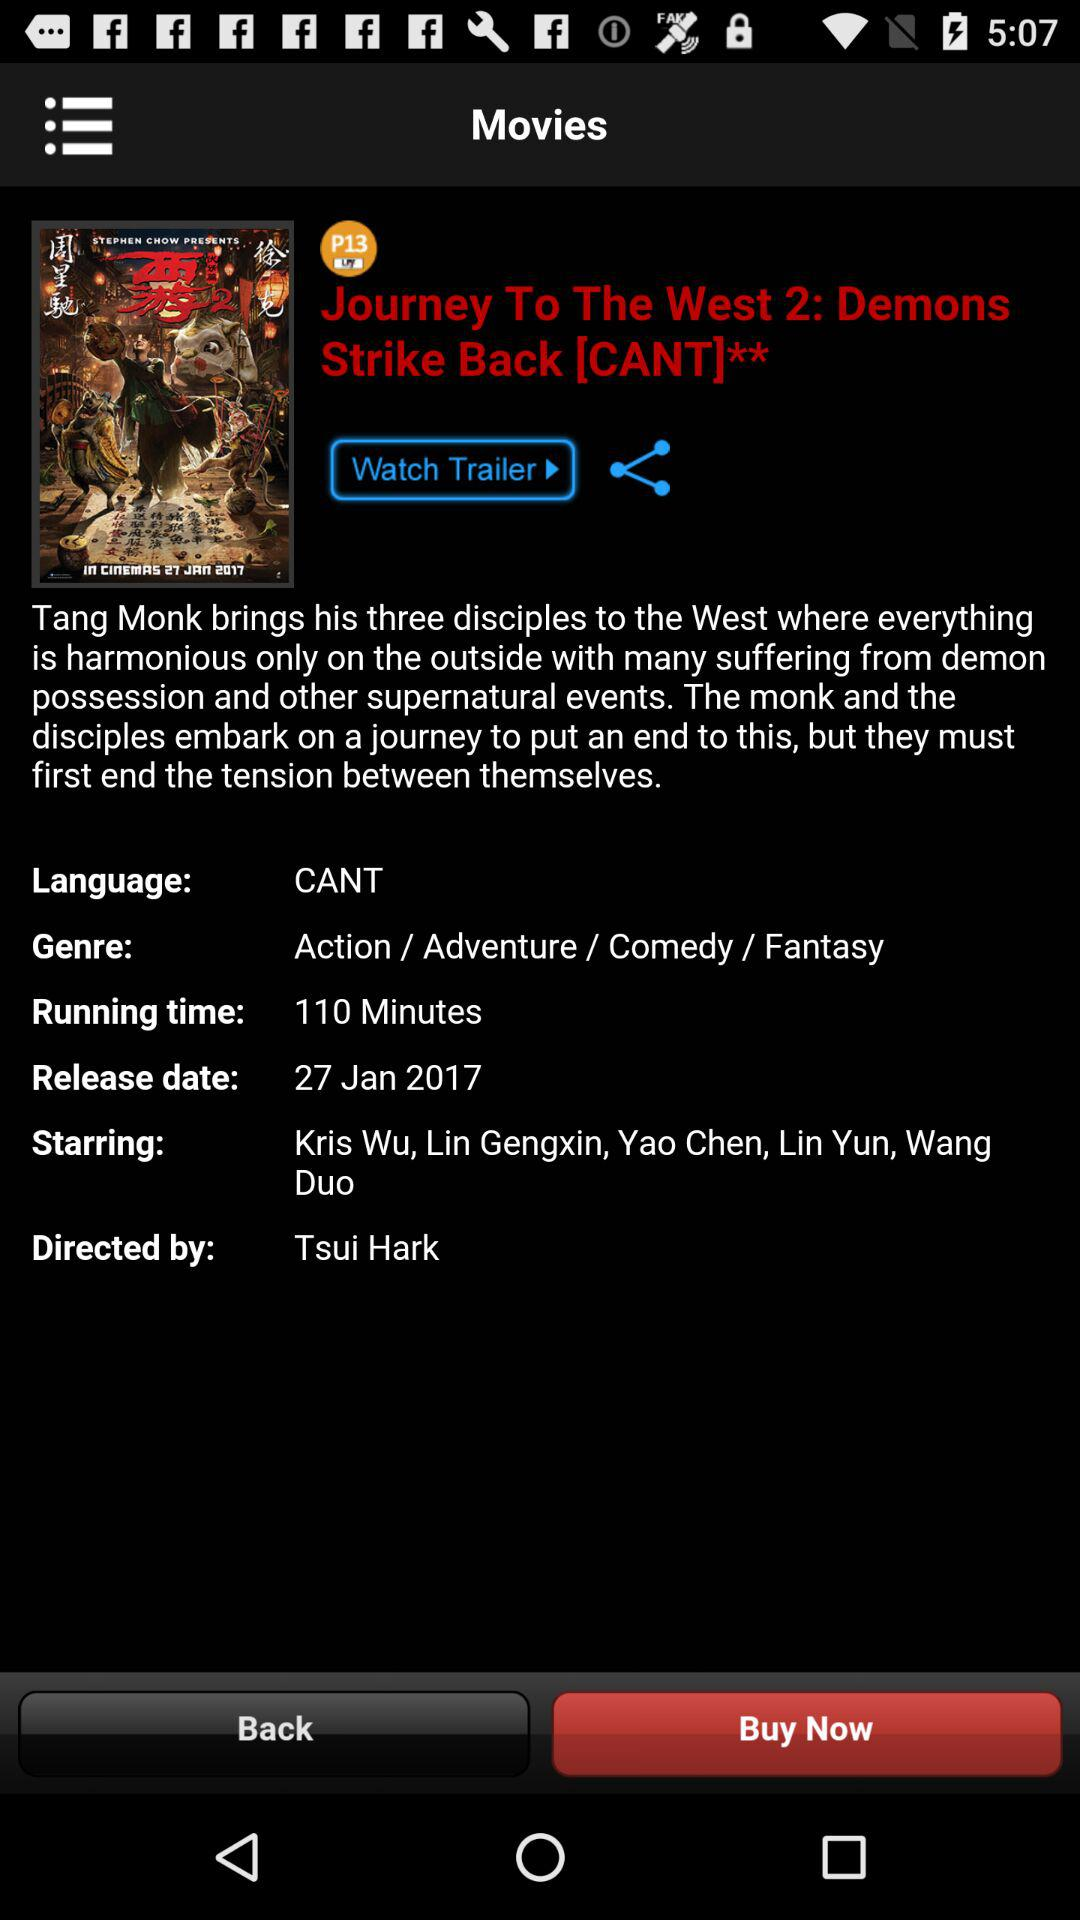What is the language? The language is CANT. 